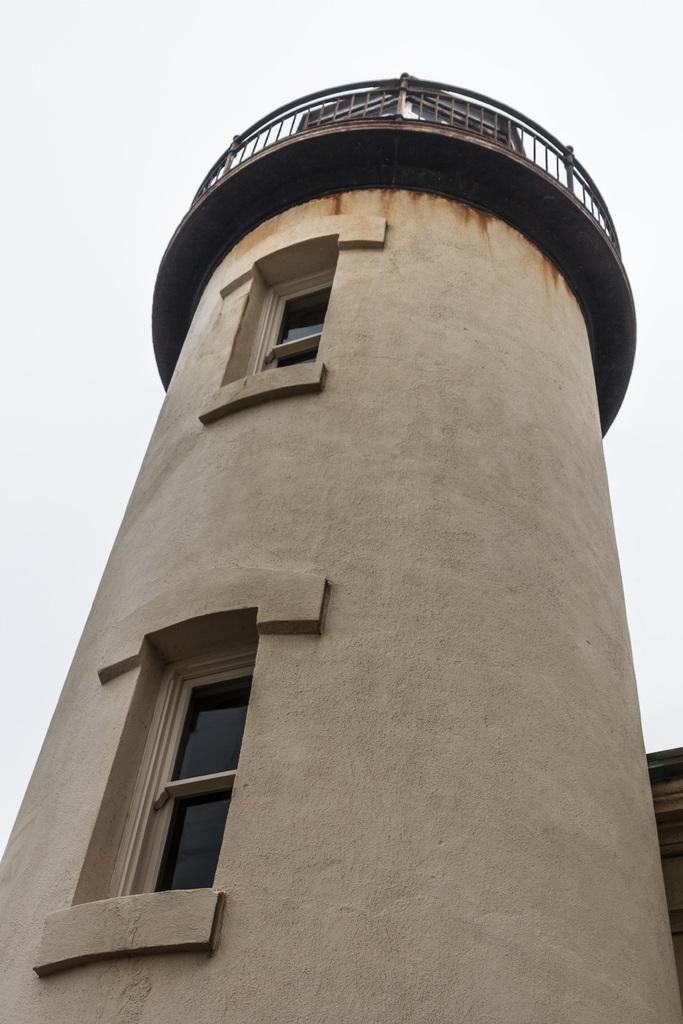What is the main structure in the image? There is a tall tower in the image. How many windows can be seen on the tower? The tower has two windows. What type of growth can be seen on the tower in the image? There is no growth visible on the tower in the image. Can you describe the sense of the tower in the image? The tower does not have a sense, as it is an inanimate object. 